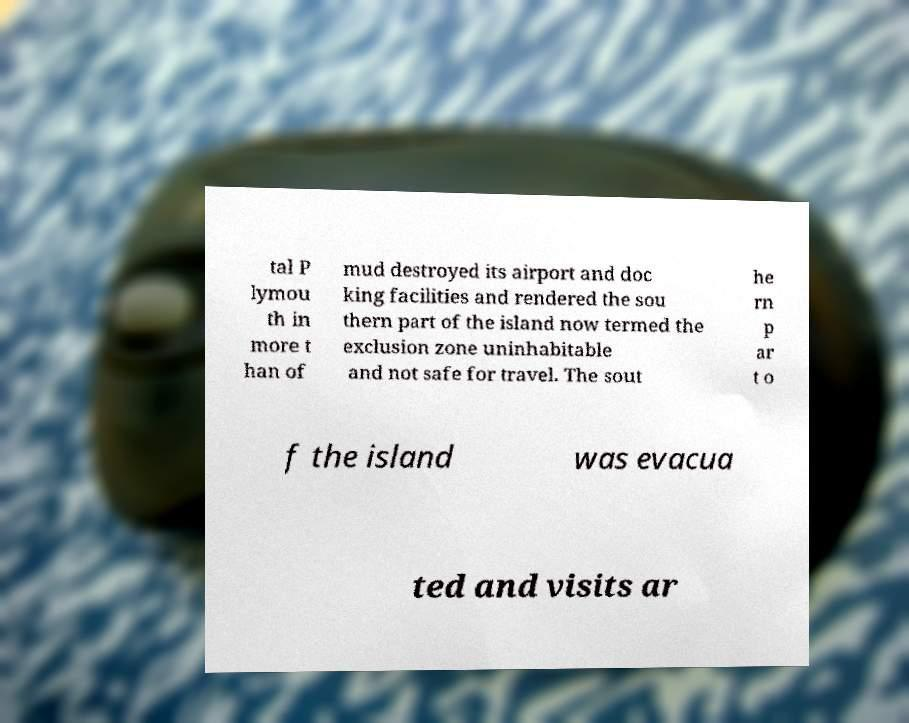For documentation purposes, I need the text within this image transcribed. Could you provide that? tal P lymou th in more t han of mud destroyed its airport and doc king facilities and rendered the sou thern part of the island now termed the exclusion zone uninhabitable and not safe for travel. The sout he rn p ar t o f the island was evacua ted and visits ar 